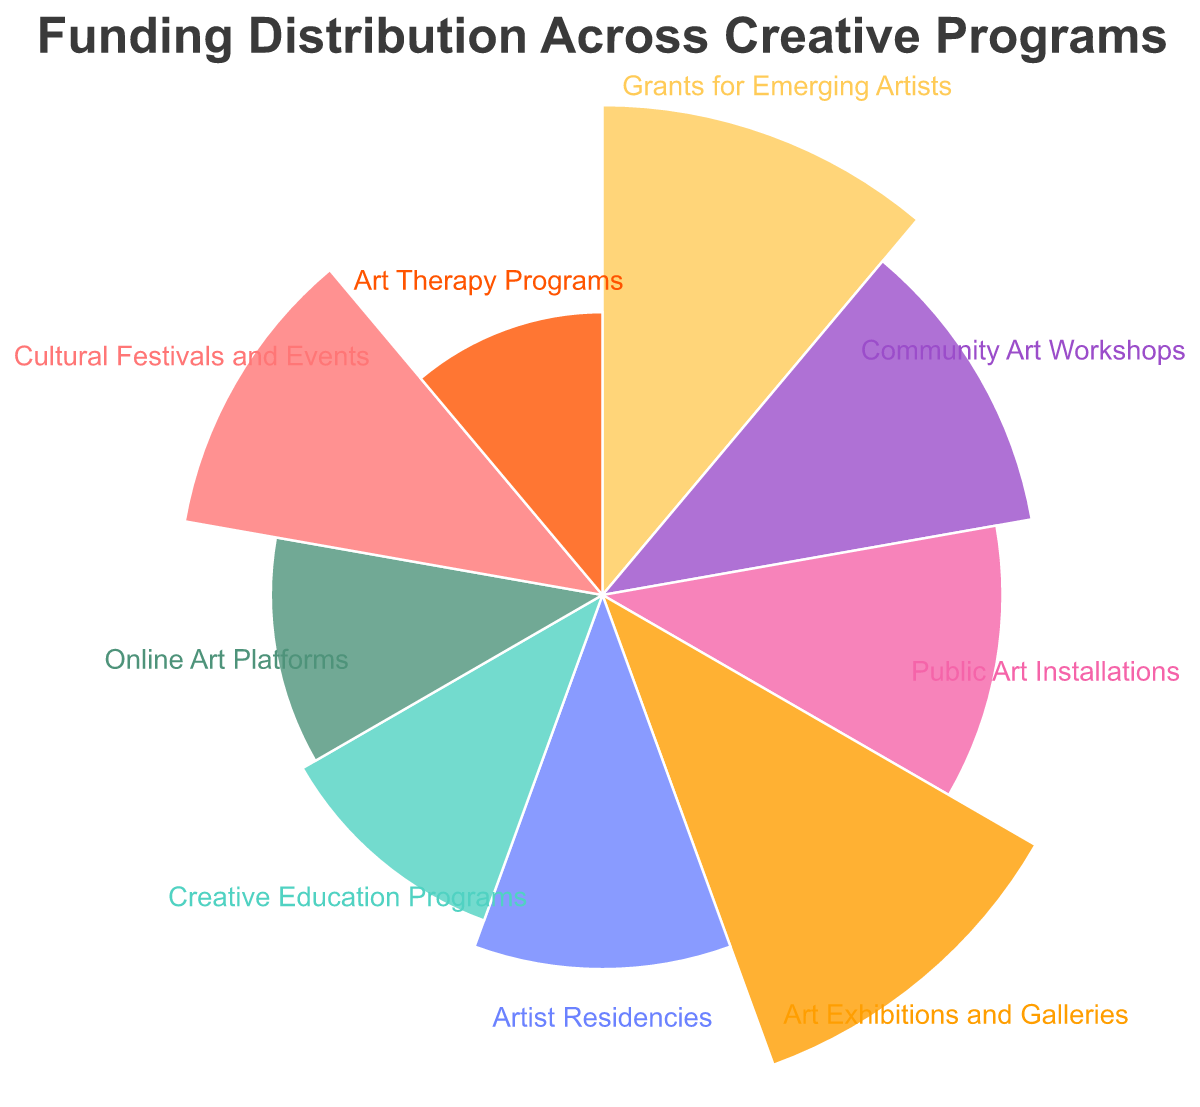What is the title of the plot? The title is displayed at the top of the chart and reads "Funding Distribution Across Creative Programs".
Answer: Funding Distribution Across Creative Programs Which category receives the highest funding? The largest arc in the polar chart corresponds to "Art Exhibitions and Galleries", indicating it receives the highest funding.
Answer: Art Exhibitions and Galleries How much funding is allocated to Online Art Platforms? By checking the arc labeled "Online Art Platforms", we see it represents $55,000 in funding.
Answer: $55,000 What is the total funding allocated to Community Art Workshops and Cultural Festivals and Events combined? The funding for Community Art Workshops is $95,000 and for Cultural Festivals and Events is $90,000; adding these together gives $185,000.
Answer: $185,000 Which category receives less funding: Artist Residencies or Creative Education Programs? The arc for Creative Education Programs ($60,000) is longer than the arc for Artist Residencies ($70,000); therefore, Creative Education Programs receives less funding.
Answer: Creative Education Programs Which program gets the least amount of funding? The smallest arc in the chart is for "Art Therapy Programs", indicating it has the least funding.
Answer: Art Therapy Programs Is the funding for Public Art Installations greater than the funding for Art Therapy Programs? The arc for Public Art Installations ($80,000) is indeed larger than the arc for Art Therapy Programs ($40,000).
Answer: Yes What is the difference in funding between Grants for Emerging Artists and Artist Residencies? Grants for Emerging Artists receive $120,000, while Artist Residencies get $70,000. The difference between these amounts is $50,000.
Answer: $50,000 How does the funding for Community Art Workshops compare to that for Online Art Platforms? The funding for Community Art Workshops ($95,000) is significantly higher than that for Online Art Platforms ($55,000).
Answer: Community Art Workshops receives more What is the average funding amount across all the listed categories? Adding all funding amounts (120,000 + 95,000 + 80,000 + 125,000 + 70,000 + 60,000 + 55,000 + 90,000 + 40,000) gives $735,000; dividing by the 9 categories, the average is approximately $81,667.
Answer: $81,667 